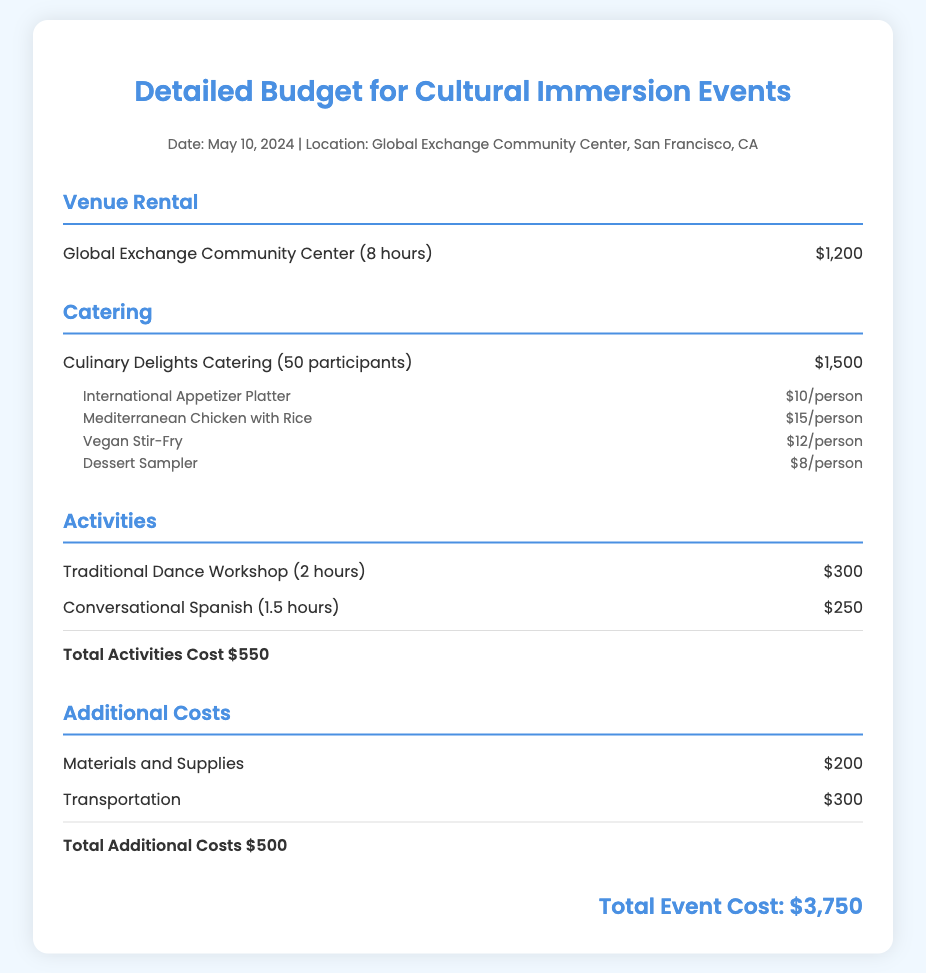What is the date of the event? The date of the event is mentioned in the event info section of the document.
Answer: May 10, 2024 What is the venue rental cost? The venue rental cost is listed under the venue rental section.
Answer: $1,200 How much does each participant's catering cost for the Mediterranean Chicken with Rice? The cost per person for the Mediterranean Chicken with Rice is stated in the catering section.
Answer: $15/person What is the total cost for activities? The total activities cost is summed up in the activities section of the document.
Answer: $550 What additional cost is associated with transportation? The transportation cost is specified in the additional costs section.
Answer: $300 What is the total event cost? The total event cost is calculated as the sum of all expenses in the document.
Answer: $3,750 How long is the Traditional Dance Workshop? The duration of the Traditional Dance Workshop is outlined in the activities section.
Answer: 2 hours What is the total for materials and supplies? The total cost for materials and supplies is included in the additional costs section.
Answer: $200 How many participants are there for catering? The number of participants for catering is specified in the catering section.
Answer: 50 participants 